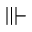Convert formula to latex. <formula><loc_0><loc_0><loc_500><loc_500>\ V v d a s h</formula> 